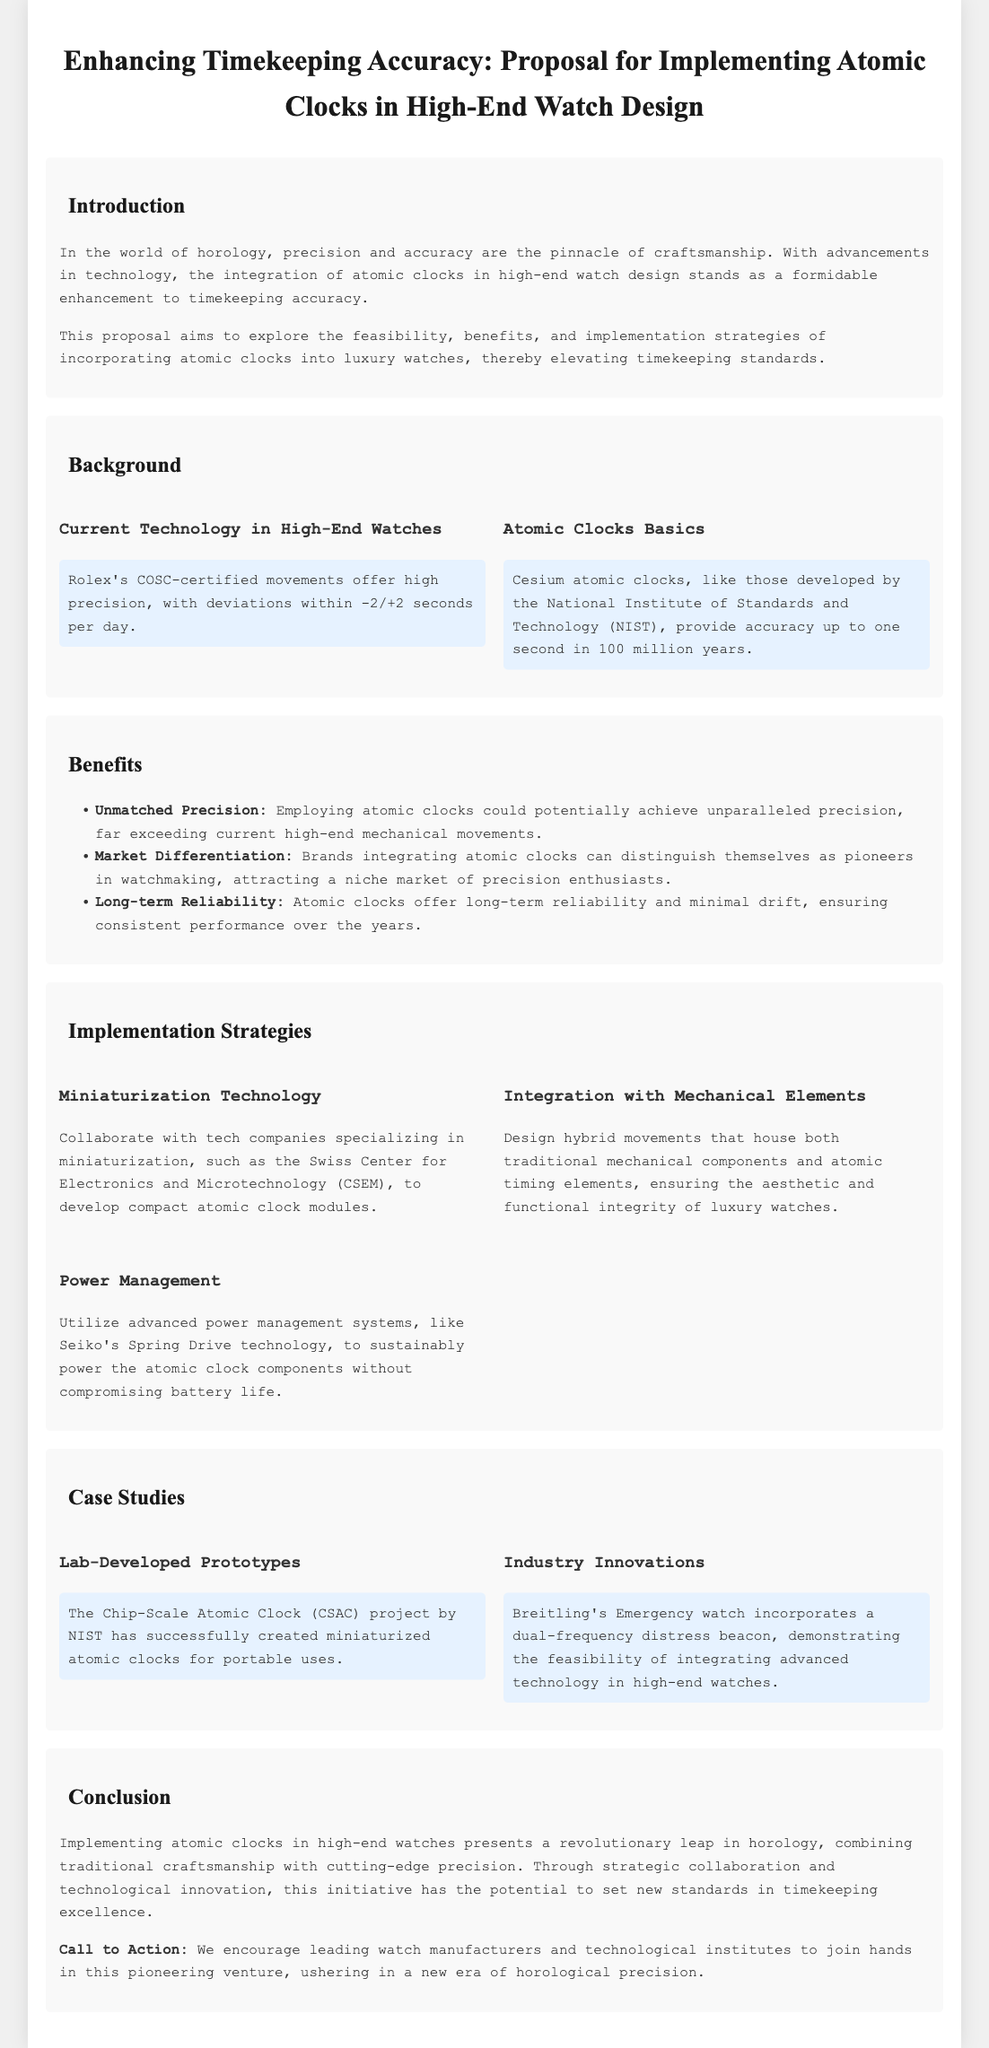What is the main goal of the proposal? The proposal aims to explore the feasibility, benefits, and implementation strategies of incorporating atomic clocks into luxury watches.
Answer: Incorporate atomic clocks into luxury watches What movement certification is mentioned for Rolex? The document states that Rolex's movements are COSC-certified, ensuring high precision.
Answer: COSC-certified What is the accuracy of cesium atomic clocks? Cesium atomic clocks provide accuracy up to one second in 100 million years.
Answer: One second in 100 million years What is one proposed strategy for power management? The proposal suggests utilizing advanced power management systems like Seiko's Spring Drive technology.
Answer: Seiko's Spring Drive technology Which company is mentioned as collaborating on miniaturization technology? The proposal mentions collaborating with the Swiss Center for Electronics and Microtechnology (CSEM).
Answer: Swiss Center for Electronics and Microtechnology What distinguishes brands that implement atomic clocks according to the document? Brands that integrate atomic clocks can distinguish themselves as pioneers in watchmaking.
Answer: Pioneers in watchmaking What is the expected market for atomic clock-integrated watches? The niche market includes precision enthusiasts attracted by unmatched precision.
Answer: Precision enthusiasts Which watch is cited as an example of integrating advanced technology? Breitling's Emergency watch is cited for incorporating a dual-frequency distress beacon.
Answer: Breitling's Emergency watch 